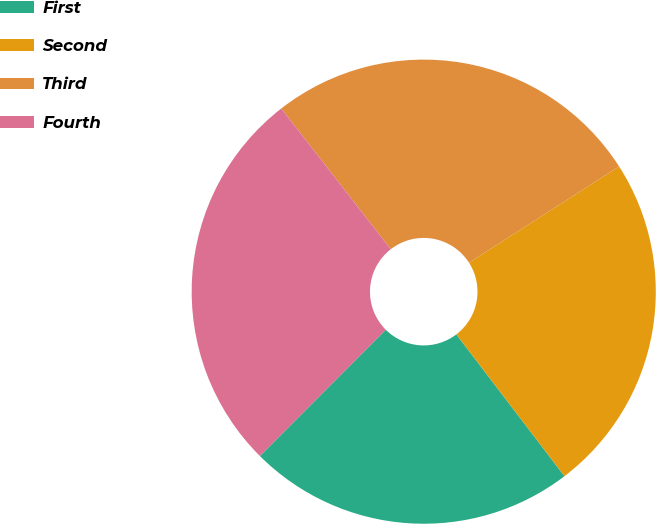Convert chart. <chart><loc_0><loc_0><loc_500><loc_500><pie_chart><fcel>First<fcel>Second<fcel>Third<fcel>Fourth<nl><fcel>22.85%<fcel>23.7%<fcel>26.45%<fcel>27.0%<nl></chart> 